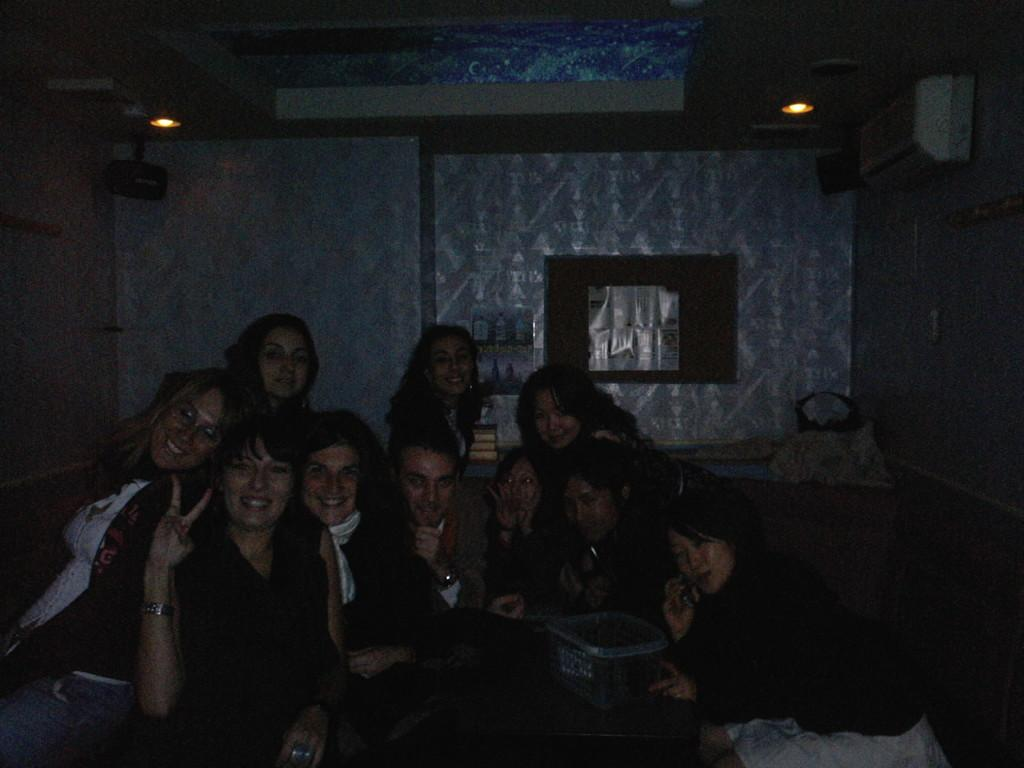What is happening in the image involving a group of people? There is a group of women in the image, and they are sitting together. What might be the reason for the women to be sitting together? The women are posing for a photograph. What can be seen in the background of the image? There is a wall and objects on shelves in the background of the image. What type of waves can be seen crashing against the shore in the image? There are no waves or shore visible in the image; it features a group of women sitting together and posing for a photograph. 